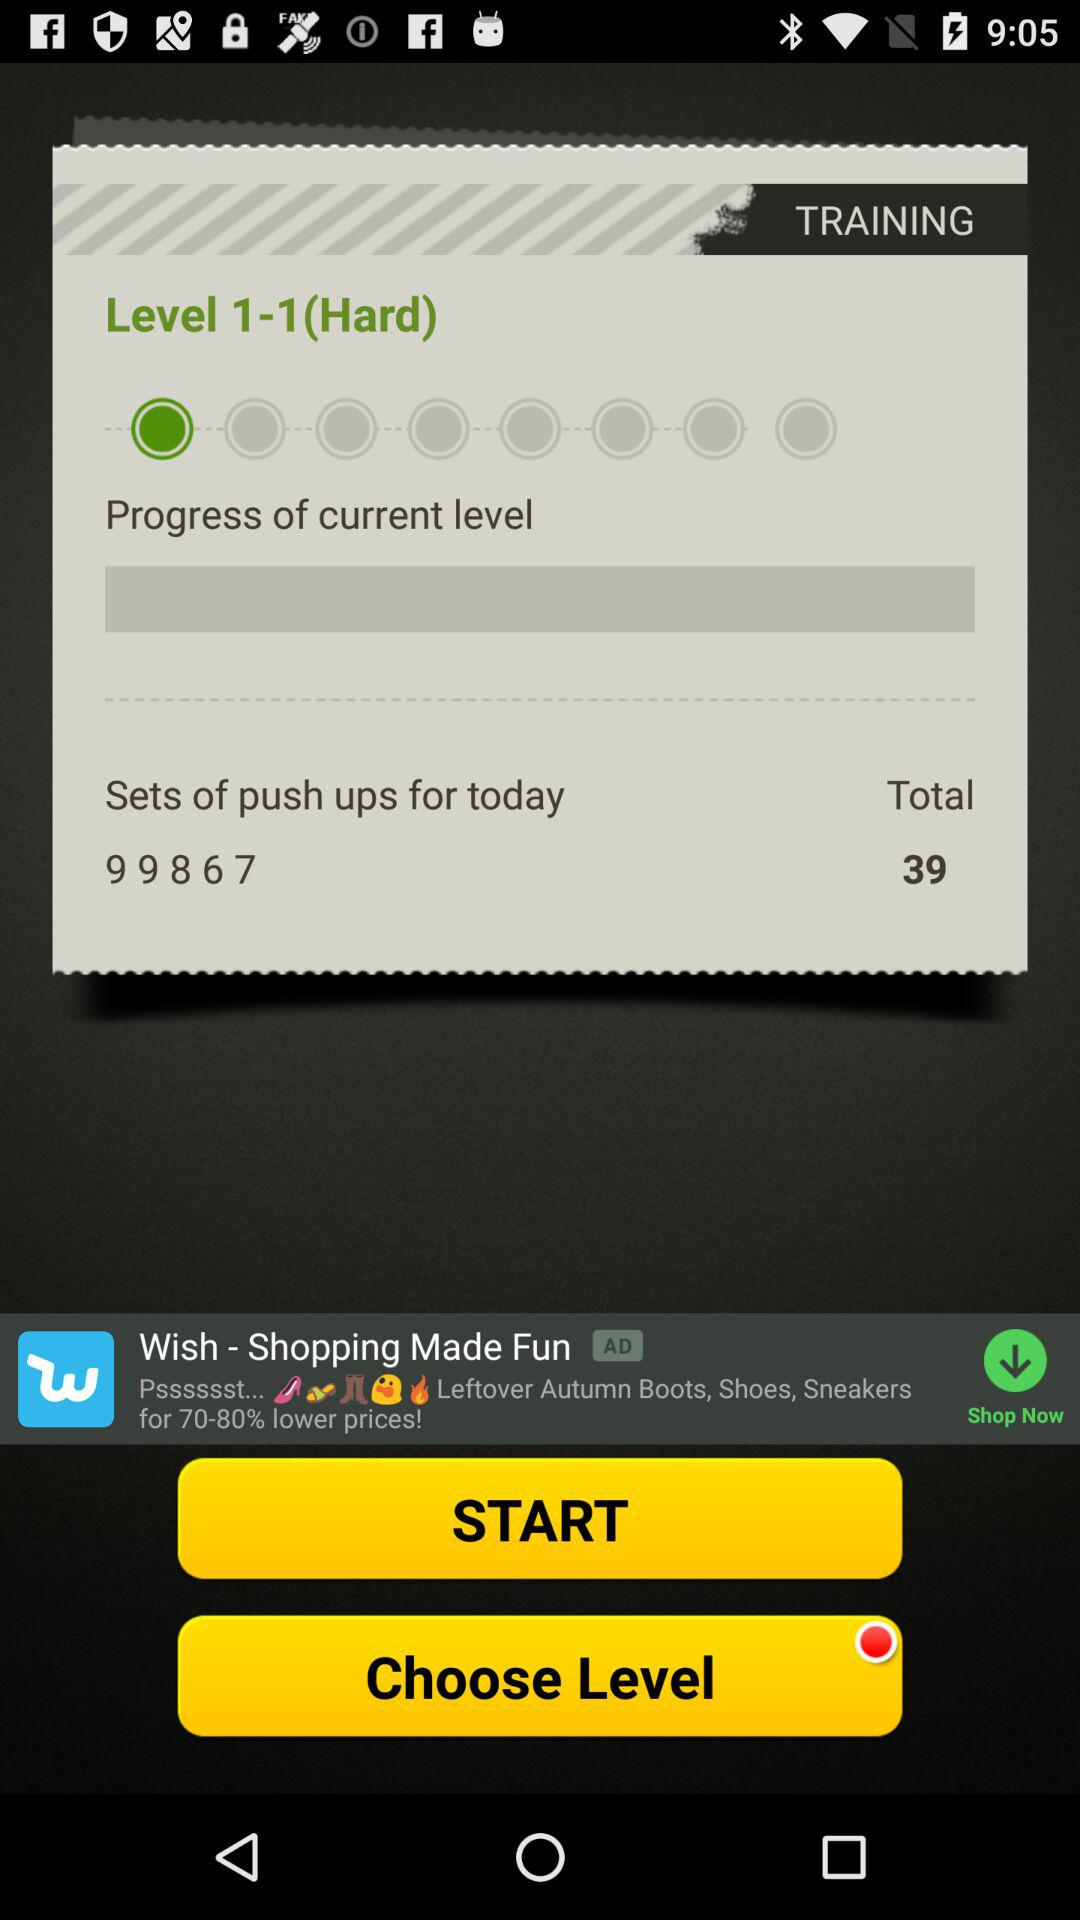What's the level? The level is 1-1(Hard). 